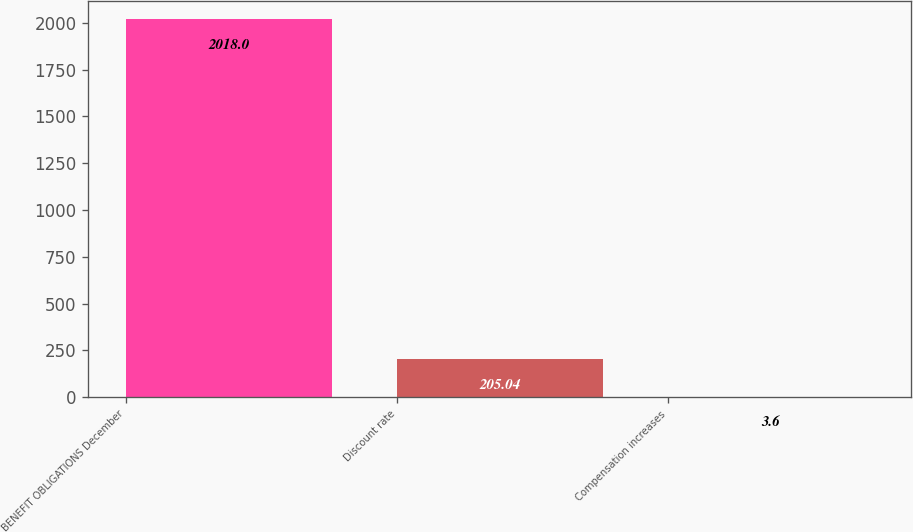Convert chart to OTSL. <chart><loc_0><loc_0><loc_500><loc_500><bar_chart><fcel>BENEFIT OBLIGATIONS December<fcel>Discount rate<fcel>Compensation increases<nl><fcel>2018<fcel>205.04<fcel>3.6<nl></chart> 